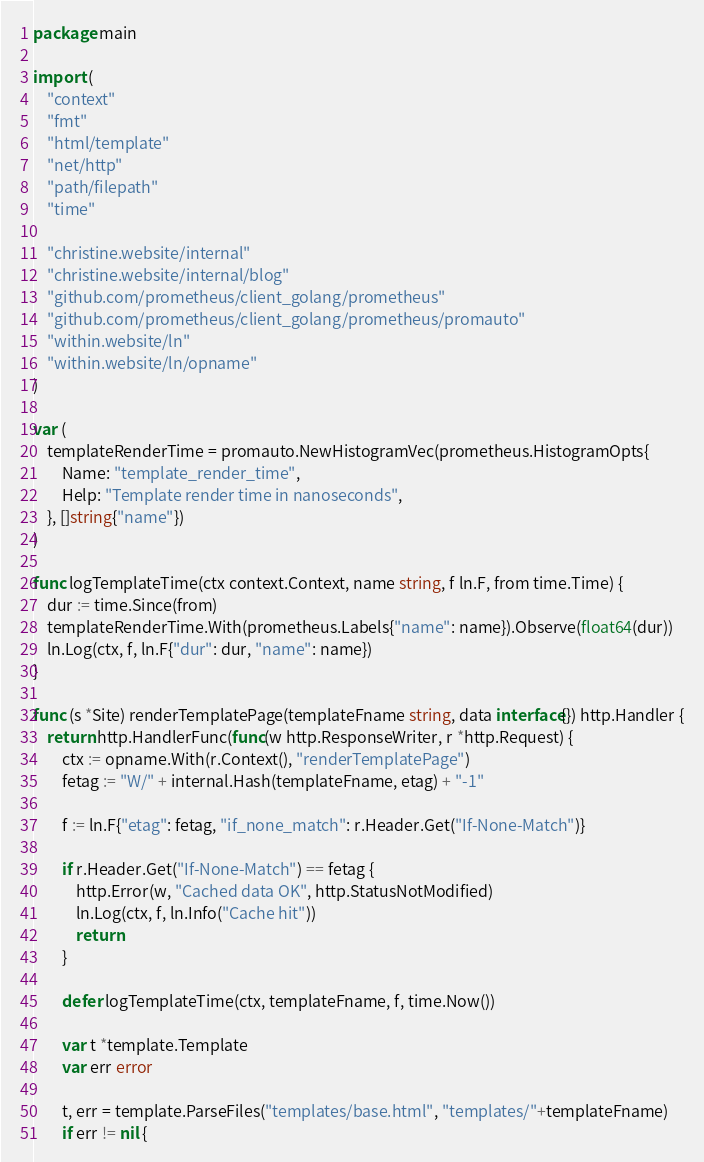Convert code to text. <code><loc_0><loc_0><loc_500><loc_500><_Go_>package main

import (
	"context"
	"fmt"
	"html/template"
	"net/http"
	"path/filepath"
	"time"

	"christine.website/internal"
	"christine.website/internal/blog"
	"github.com/prometheus/client_golang/prometheus"
	"github.com/prometheus/client_golang/prometheus/promauto"
	"within.website/ln"
	"within.website/ln/opname"
)

var (
	templateRenderTime = promauto.NewHistogramVec(prometheus.HistogramOpts{
		Name: "template_render_time",
		Help: "Template render time in nanoseconds",
	}, []string{"name"})
)

func logTemplateTime(ctx context.Context, name string, f ln.F, from time.Time) {
	dur := time.Since(from)
	templateRenderTime.With(prometheus.Labels{"name": name}).Observe(float64(dur))
	ln.Log(ctx, f, ln.F{"dur": dur, "name": name})
}

func (s *Site) renderTemplatePage(templateFname string, data interface{}) http.Handler {
	return http.HandlerFunc(func(w http.ResponseWriter, r *http.Request) {
		ctx := opname.With(r.Context(), "renderTemplatePage")
		fetag := "W/" + internal.Hash(templateFname, etag) + "-1"

		f := ln.F{"etag": fetag, "if_none_match": r.Header.Get("If-None-Match")}

		if r.Header.Get("If-None-Match") == fetag {
			http.Error(w, "Cached data OK", http.StatusNotModified)
			ln.Log(ctx, f, ln.Info("Cache hit"))
			return
		}

		defer logTemplateTime(ctx, templateFname, f, time.Now())

		var t *template.Template
		var err error

		t, err = template.ParseFiles("templates/base.html", "templates/"+templateFname)
		if err != nil {</code> 